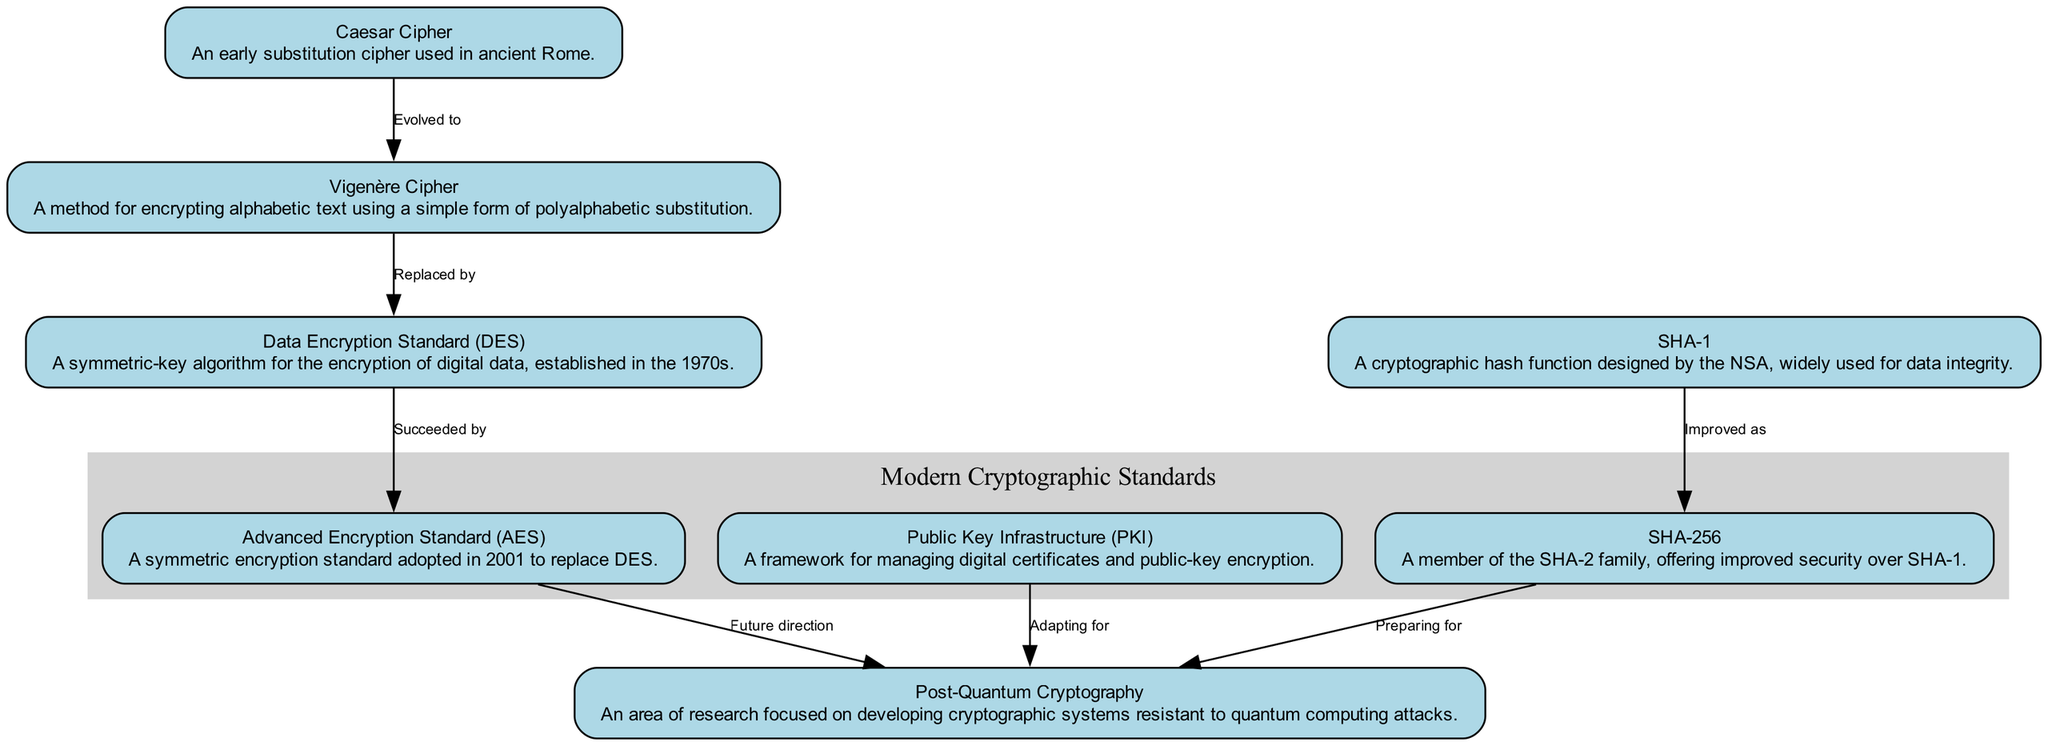What is the earliest cryptographic standard shown in the diagram? The diagram shows the "Caesar Cipher" as the first node, which represents the earliest cryptographic standard.
Answer: Caesar Cipher Which cryptographic standard succeeded the Data Encryption Standard? The diagram indicates that the "Advanced Encryption Standard (AES)" succeeded "Data Encryption Standard (DES)," as shown by the directed edge from DES to AES.
Answer: Advanced Encryption Standard (AES) How many cryptographic standards are depicted in the diagram? The diagram includes a total of eight nodes representing different cryptographic standards, which can be counted directly from the visual layout.
Answer: Eight What relationship is indicated between SHA-1 and SHA-256? The relationship line marked "Improved as" shows that SHA-256 is an enhancement of SHA-1, as illustrated by the directed edge from SHA-1 to SHA-256.
Answer: Improved as Which node points towards Post-Quantum Cryptography from the Advanced Encryption Standard? The directed edge from "Advanced Encryption Standard (AES)" to "Post-Quantum Cryptography" indicates a planned future direction, which shows that AES points towards Post-Quantum Cryptography.
Answer: Post-Quantum Cryptography How does Public Key Infrastructure contribute to the evolution of cryptographic standards? The diagram indicates that Public Key Infrastructure adapts for Post-Quantum Cryptography, illustrating its role in evolving towards modern cryptographic adaptations.
Answer: Adapting for What kind of node is SHA-256 in relation to SHA-1? SHA-256 is a successor to SHA-1, reflecting a relationship of improvement, as denoted by the directed edge labeled "Improved as" between the two nodes.
Answer: Successor Which subgraph contains the Advanced Encryption Standard? The "Modern Cryptographic Standards" subgraph includes "Advanced Encryption Standard (AES)," which groups it among other recent cryptographic standards.
Answer: Modern Cryptographic Standards 